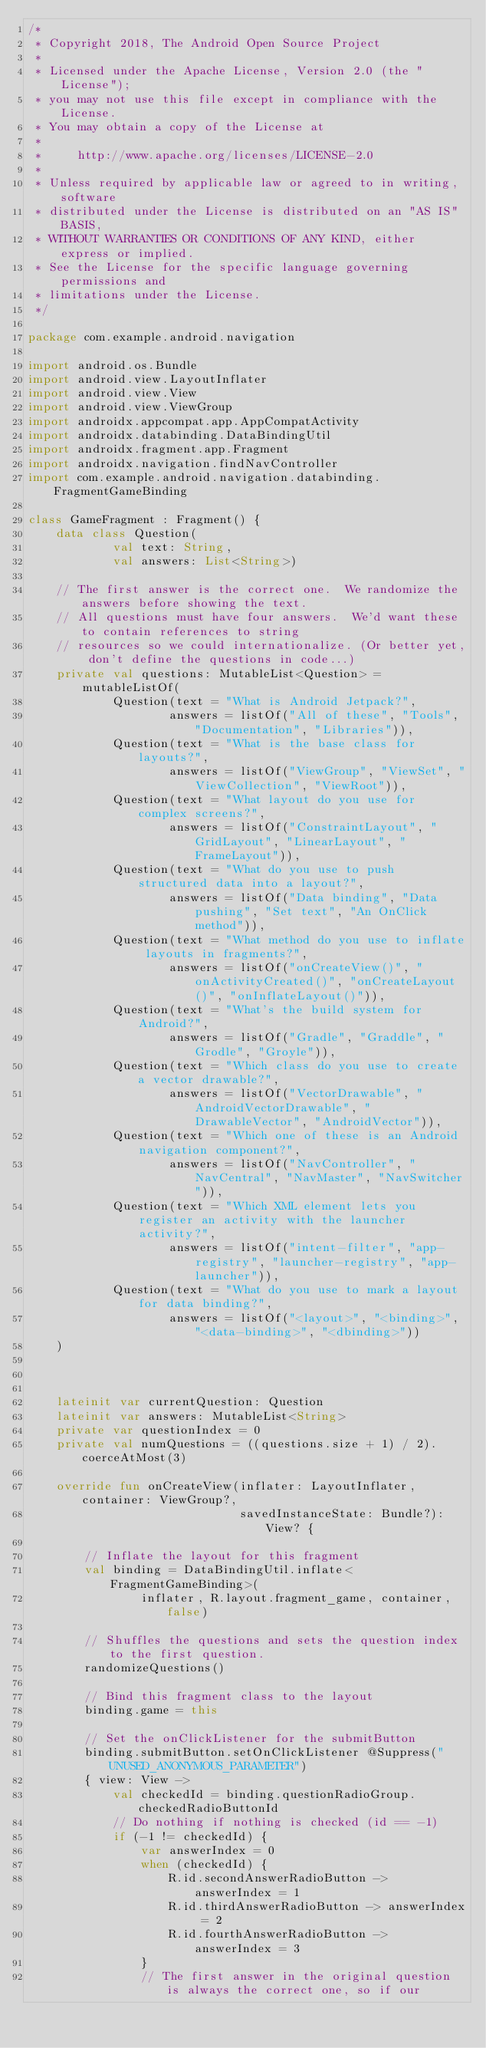<code> <loc_0><loc_0><loc_500><loc_500><_Kotlin_>/*
 * Copyright 2018, The Android Open Source Project
 *
 * Licensed under the Apache License, Version 2.0 (the "License");
 * you may not use this file except in compliance with the License.
 * You may obtain a copy of the License at
 *
 *     http://www.apache.org/licenses/LICENSE-2.0
 *
 * Unless required by applicable law or agreed to in writing, software
 * distributed under the License is distributed on an "AS IS" BASIS,
 * WITHOUT WARRANTIES OR CONDITIONS OF ANY KIND, either express or implied.
 * See the License for the specific language governing permissions and
 * limitations under the License.
 */

package com.example.android.navigation

import android.os.Bundle
import android.view.LayoutInflater
import android.view.View
import android.view.ViewGroup
import androidx.appcompat.app.AppCompatActivity
import androidx.databinding.DataBindingUtil
import androidx.fragment.app.Fragment
import androidx.navigation.findNavController
import com.example.android.navigation.databinding.FragmentGameBinding

class GameFragment : Fragment() {
    data class Question(
            val text: String,
            val answers: List<String>)

    // The first answer is the correct one.  We randomize the answers before showing the text.
    // All questions must have four answers.  We'd want these to contain references to string
    // resources so we could internationalize. (Or better yet, don't define the questions in code...)
    private val questions: MutableList<Question> = mutableListOf(
            Question(text = "What is Android Jetpack?",
                    answers = listOf("All of these", "Tools", "Documentation", "Libraries")),
            Question(text = "What is the base class for layouts?",
                    answers = listOf("ViewGroup", "ViewSet", "ViewCollection", "ViewRoot")),
            Question(text = "What layout do you use for complex screens?",
                    answers = listOf("ConstraintLayout", "GridLayout", "LinearLayout", "FrameLayout")),
            Question(text = "What do you use to push structured data into a layout?",
                    answers = listOf("Data binding", "Data pushing", "Set text", "An OnClick method")),
            Question(text = "What method do you use to inflate layouts in fragments?",
                    answers = listOf("onCreateView()", "onActivityCreated()", "onCreateLayout()", "onInflateLayout()")),
            Question(text = "What's the build system for Android?",
                    answers = listOf("Gradle", "Graddle", "Grodle", "Groyle")),
            Question(text = "Which class do you use to create a vector drawable?",
                    answers = listOf("VectorDrawable", "AndroidVectorDrawable", "DrawableVector", "AndroidVector")),
            Question(text = "Which one of these is an Android navigation component?",
                    answers = listOf("NavController", "NavCentral", "NavMaster", "NavSwitcher")),
            Question(text = "Which XML element lets you register an activity with the launcher activity?",
                    answers = listOf("intent-filter", "app-registry", "launcher-registry", "app-launcher")),
            Question(text = "What do you use to mark a layout for data binding?",
                    answers = listOf("<layout>", "<binding>", "<data-binding>", "<dbinding>"))
    )



    lateinit var currentQuestion: Question
    lateinit var answers: MutableList<String>
    private var questionIndex = 0
    private val numQuestions = ((questions.size + 1) / 2).coerceAtMost(3)

    override fun onCreateView(inflater: LayoutInflater, container: ViewGroup?,
                              savedInstanceState: Bundle?): View? {

        // Inflate the layout for this fragment
        val binding = DataBindingUtil.inflate<FragmentGameBinding>(
                inflater, R.layout.fragment_game, container, false)

        // Shuffles the questions and sets the question index to the first question.
        randomizeQuestions()

        // Bind this fragment class to the layout
        binding.game = this

        // Set the onClickListener for the submitButton
        binding.submitButton.setOnClickListener @Suppress("UNUSED_ANONYMOUS_PARAMETER")
        { view: View ->
            val checkedId = binding.questionRadioGroup.checkedRadioButtonId
            // Do nothing if nothing is checked (id == -1)
            if (-1 != checkedId) {
                var answerIndex = 0
                when (checkedId) {
                    R.id.secondAnswerRadioButton -> answerIndex = 1
                    R.id.thirdAnswerRadioButton -> answerIndex = 2
                    R.id.fourthAnswerRadioButton -> answerIndex = 3
                }
                // The first answer in the original question is always the correct one, so if our</code> 